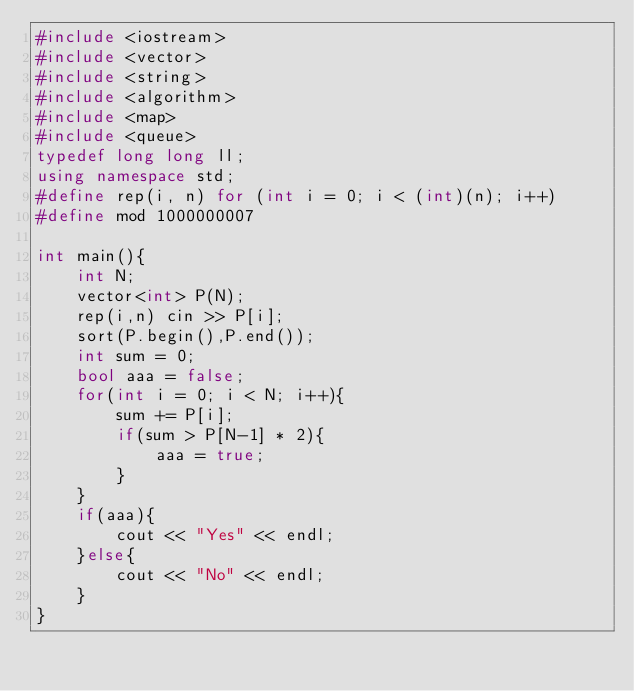Convert code to text. <code><loc_0><loc_0><loc_500><loc_500><_C++_>#include <iostream>
#include <vector>
#include <string>
#include <algorithm>
#include <map>
#include <queue>
typedef long long ll;
using namespace std;
#define rep(i, n) for (int i = 0; i < (int)(n); i++)
#define mod 1000000007

int main(){
	int N;
	vector<int> P(N);
	rep(i,n) cin >> P[i];
	sort(P.begin(),P.end());
	int sum = 0;
	bool aaa = false;
	for(int i = 0; i < N; i++){
		sum += P[i];
		if(sum > P[N-1] * 2){
			aaa = true;
		}
	}
	if(aaa){
		cout << "Yes" << endl;
	}else{
		cout << "No" << endl;
	}
}</code> 